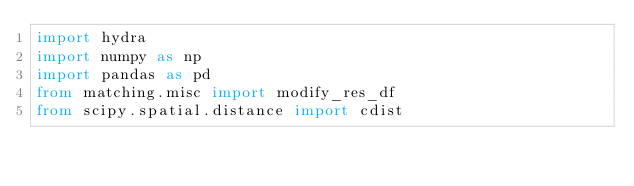<code> <loc_0><loc_0><loc_500><loc_500><_Python_>import hydra
import numpy as np
import pandas as pd
from matching.misc import modify_res_df
from scipy.spatial.distance import cdist

</code> 